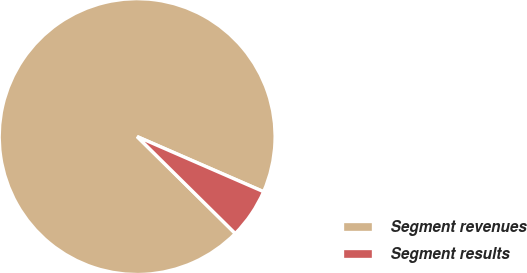Convert chart. <chart><loc_0><loc_0><loc_500><loc_500><pie_chart><fcel>Segment revenues<fcel>Segment results<nl><fcel>94.14%<fcel>5.86%<nl></chart> 